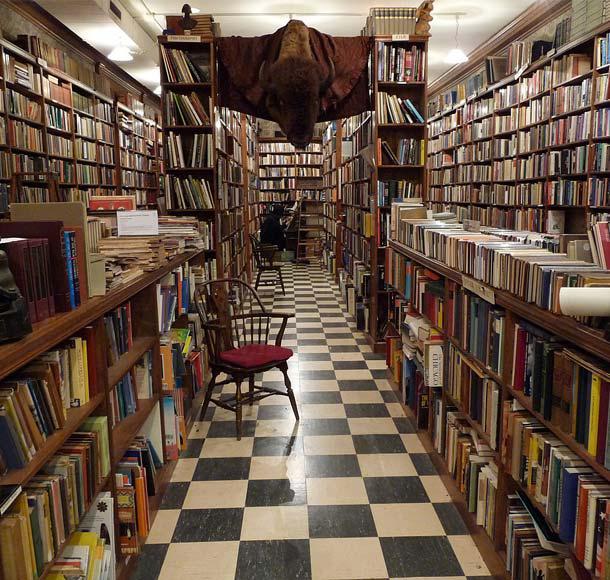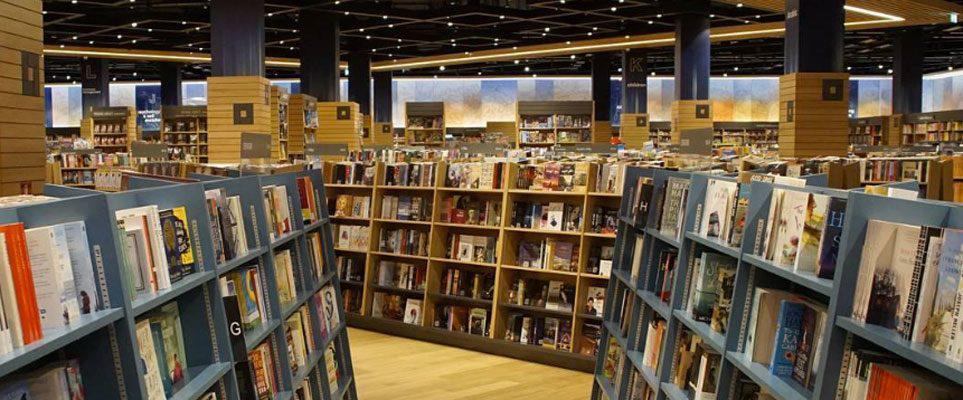The first image is the image on the left, the second image is the image on the right. Evaluate the accuracy of this statement regarding the images: "There are at least two chairs.". Is it true? Answer yes or no. Yes. 